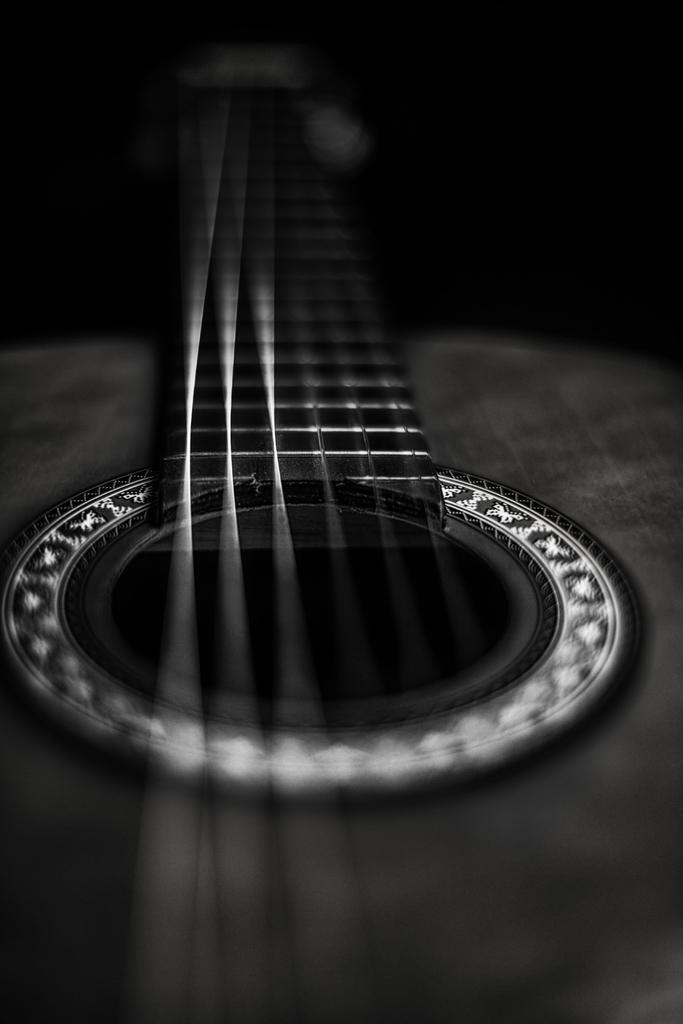Describe this image in one or two sentences. There is a gray color guitar. It has 6 strings on a silver line. 